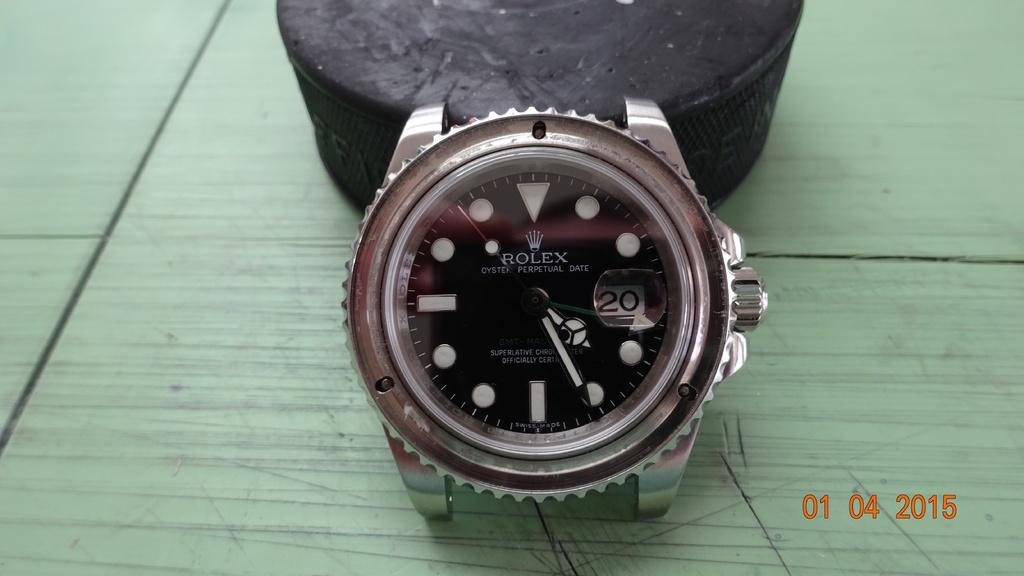<image>
Offer a succinct explanation of the picture presented. The silver metal watch on the table is a Rolex 